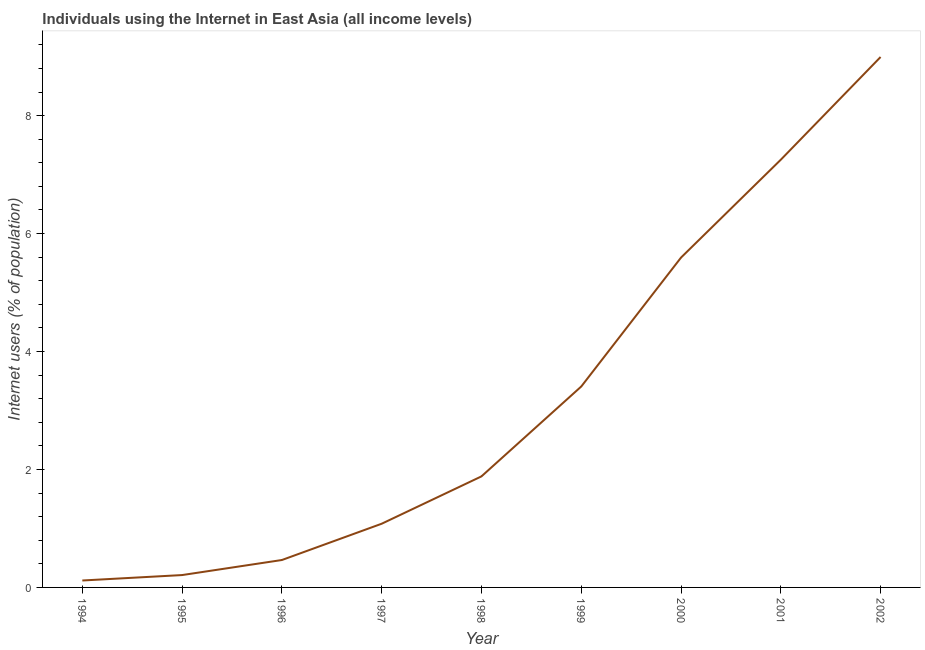What is the number of internet users in 1994?
Offer a terse response. 0.12. Across all years, what is the maximum number of internet users?
Your answer should be very brief. 8.99. Across all years, what is the minimum number of internet users?
Provide a succinct answer. 0.12. In which year was the number of internet users minimum?
Provide a succinct answer. 1994. What is the sum of the number of internet users?
Provide a short and direct response. 29. What is the difference between the number of internet users in 1995 and 2002?
Make the answer very short. -8.78. What is the average number of internet users per year?
Your answer should be compact. 3.22. What is the median number of internet users?
Keep it short and to the point. 1.88. In how many years, is the number of internet users greater than 3.6 %?
Your answer should be very brief. 3. What is the ratio of the number of internet users in 1995 to that in 1998?
Provide a succinct answer. 0.11. What is the difference between the highest and the second highest number of internet users?
Give a very brief answer. 1.74. What is the difference between the highest and the lowest number of internet users?
Keep it short and to the point. 8.88. How many lines are there?
Keep it short and to the point. 1. What is the difference between two consecutive major ticks on the Y-axis?
Your response must be concise. 2. Are the values on the major ticks of Y-axis written in scientific E-notation?
Offer a very short reply. No. Does the graph contain any zero values?
Offer a terse response. No. Does the graph contain grids?
Provide a succinct answer. No. What is the title of the graph?
Keep it short and to the point. Individuals using the Internet in East Asia (all income levels). What is the label or title of the X-axis?
Offer a terse response. Year. What is the label or title of the Y-axis?
Keep it short and to the point. Internet users (% of population). What is the Internet users (% of population) of 1994?
Offer a terse response. 0.12. What is the Internet users (% of population) of 1995?
Your response must be concise. 0.21. What is the Internet users (% of population) in 1996?
Your answer should be very brief. 0.46. What is the Internet users (% of population) in 1997?
Provide a short and direct response. 1.08. What is the Internet users (% of population) in 1998?
Provide a succinct answer. 1.88. What is the Internet users (% of population) in 1999?
Your answer should be very brief. 3.41. What is the Internet users (% of population) of 2000?
Offer a terse response. 5.59. What is the Internet users (% of population) of 2001?
Your answer should be very brief. 7.25. What is the Internet users (% of population) of 2002?
Offer a terse response. 8.99. What is the difference between the Internet users (% of population) in 1994 and 1995?
Offer a terse response. -0.09. What is the difference between the Internet users (% of population) in 1994 and 1996?
Ensure brevity in your answer.  -0.35. What is the difference between the Internet users (% of population) in 1994 and 1997?
Provide a short and direct response. -0.96. What is the difference between the Internet users (% of population) in 1994 and 1998?
Give a very brief answer. -1.77. What is the difference between the Internet users (% of population) in 1994 and 1999?
Keep it short and to the point. -3.29. What is the difference between the Internet users (% of population) in 1994 and 2000?
Provide a succinct answer. -5.48. What is the difference between the Internet users (% of population) in 1994 and 2001?
Your response must be concise. -7.13. What is the difference between the Internet users (% of population) in 1994 and 2002?
Provide a succinct answer. -8.88. What is the difference between the Internet users (% of population) in 1995 and 1996?
Give a very brief answer. -0.26. What is the difference between the Internet users (% of population) in 1995 and 1997?
Offer a terse response. -0.87. What is the difference between the Internet users (% of population) in 1995 and 1998?
Offer a terse response. -1.67. What is the difference between the Internet users (% of population) in 1995 and 1999?
Provide a succinct answer. -3.2. What is the difference between the Internet users (% of population) in 1995 and 2000?
Provide a succinct answer. -5.38. What is the difference between the Internet users (% of population) in 1995 and 2001?
Provide a short and direct response. -7.04. What is the difference between the Internet users (% of population) in 1995 and 2002?
Ensure brevity in your answer.  -8.78. What is the difference between the Internet users (% of population) in 1996 and 1997?
Your answer should be very brief. -0.62. What is the difference between the Internet users (% of population) in 1996 and 1998?
Ensure brevity in your answer.  -1.42. What is the difference between the Internet users (% of population) in 1996 and 1999?
Your response must be concise. -2.94. What is the difference between the Internet users (% of population) in 1996 and 2000?
Keep it short and to the point. -5.13. What is the difference between the Internet users (% of population) in 1996 and 2001?
Offer a very short reply. -6.79. What is the difference between the Internet users (% of population) in 1996 and 2002?
Provide a short and direct response. -8.53. What is the difference between the Internet users (% of population) in 1997 and 1998?
Offer a very short reply. -0.8. What is the difference between the Internet users (% of population) in 1997 and 1999?
Your answer should be very brief. -2.33. What is the difference between the Internet users (% of population) in 1997 and 2000?
Provide a succinct answer. -4.51. What is the difference between the Internet users (% of population) in 1997 and 2001?
Keep it short and to the point. -6.17. What is the difference between the Internet users (% of population) in 1997 and 2002?
Your answer should be very brief. -7.91. What is the difference between the Internet users (% of population) in 1998 and 1999?
Offer a very short reply. -1.52. What is the difference between the Internet users (% of population) in 1998 and 2000?
Your response must be concise. -3.71. What is the difference between the Internet users (% of population) in 1998 and 2001?
Provide a short and direct response. -5.37. What is the difference between the Internet users (% of population) in 1998 and 2002?
Offer a terse response. -7.11. What is the difference between the Internet users (% of population) in 1999 and 2000?
Provide a succinct answer. -2.19. What is the difference between the Internet users (% of population) in 1999 and 2001?
Your answer should be very brief. -3.85. What is the difference between the Internet users (% of population) in 1999 and 2002?
Keep it short and to the point. -5.59. What is the difference between the Internet users (% of population) in 2000 and 2001?
Your answer should be compact. -1.66. What is the difference between the Internet users (% of population) in 2000 and 2002?
Provide a short and direct response. -3.4. What is the difference between the Internet users (% of population) in 2001 and 2002?
Offer a very short reply. -1.74. What is the ratio of the Internet users (% of population) in 1994 to that in 1995?
Your answer should be compact. 0.56. What is the ratio of the Internet users (% of population) in 1994 to that in 1996?
Offer a very short reply. 0.25. What is the ratio of the Internet users (% of population) in 1994 to that in 1997?
Provide a succinct answer. 0.11. What is the ratio of the Internet users (% of population) in 1994 to that in 1998?
Ensure brevity in your answer.  0.06. What is the ratio of the Internet users (% of population) in 1994 to that in 1999?
Offer a very short reply. 0.03. What is the ratio of the Internet users (% of population) in 1994 to that in 2000?
Offer a very short reply. 0.02. What is the ratio of the Internet users (% of population) in 1994 to that in 2001?
Ensure brevity in your answer.  0.02. What is the ratio of the Internet users (% of population) in 1994 to that in 2002?
Offer a terse response. 0.01. What is the ratio of the Internet users (% of population) in 1995 to that in 1996?
Provide a succinct answer. 0.45. What is the ratio of the Internet users (% of population) in 1995 to that in 1997?
Offer a very short reply. 0.19. What is the ratio of the Internet users (% of population) in 1995 to that in 1998?
Your answer should be very brief. 0.11. What is the ratio of the Internet users (% of population) in 1995 to that in 1999?
Provide a short and direct response. 0.06. What is the ratio of the Internet users (% of population) in 1995 to that in 2000?
Your answer should be compact. 0.04. What is the ratio of the Internet users (% of population) in 1995 to that in 2001?
Give a very brief answer. 0.03. What is the ratio of the Internet users (% of population) in 1995 to that in 2002?
Provide a short and direct response. 0.02. What is the ratio of the Internet users (% of population) in 1996 to that in 1997?
Offer a terse response. 0.43. What is the ratio of the Internet users (% of population) in 1996 to that in 1998?
Give a very brief answer. 0.25. What is the ratio of the Internet users (% of population) in 1996 to that in 1999?
Offer a very short reply. 0.14. What is the ratio of the Internet users (% of population) in 1996 to that in 2000?
Ensure brevity in your answer.  0.08. What is the ratio of the Internet users (% of population) in 1996 to that in 2001?
Provide a short and direct response. 0.06. What is the ratio of the Internet users (% of population) in 1996 to that in 2002?
Keep it short and to the point. 0.05. What is the ratio of the Internet users (% of population) in 1997 to that in 1998?
Give a very brief answer. 0.57. What is the ratio of the Internet users (% of population) in 1997 to that in 1999?
Ensure brevity in your answer.  0.32. What is the ratio of the Internet users (% of population) in 1997 to that in 2000?
Offer a very short reply. 0.19. What is the ratio of the Internet users (% of population) in 1997 to that in 2001?
Your response must be concise. 0.15. What is the ratio of the Internet users (% of population) in 1997 to that in 2002?
Provide a succinct answer. 0.12. What is the ratio of the Internet users (% of population) in 1998 to that in 1999?
Keep it short and to the point. 0.55. What is the ratio of the Internet users (% of population) in 1998 to that in 2000?
Ensure brevity in your answer.  0.34. What is the ratio of the Internet users (% of population) in 1998 to that in 2001?
Make the answer very short. 0.26. What is the ratio of the Internet users (% of population) in 1998 to that in 2002?
Ensure brevity in your answer.  0.21. What is the ratio of the Internet users (% of population) in 1999 to that in 2000?
Your answer should be very brief. 0.61. What is the ratio of the Internet users (% of population) in 1999 to that in 2001?
Provide a succinct answer. 0.47. What is the ratio of the Internet users (% of population) in 1999 to that in 2002?
Offer a very short reply. 0.38. What is the ratio of the Internet users (% of population) in 2000 to that in 2001?
Your response must be concise. 0.77. What is the ratio of the Internet users (% of population) in 2000 to that in 2002?
Provide a short and direct response. 0.62. What is the ratio of the Internet users (% of population) in 2001 to that in 2002?
Make the answer very short. 0.81. 